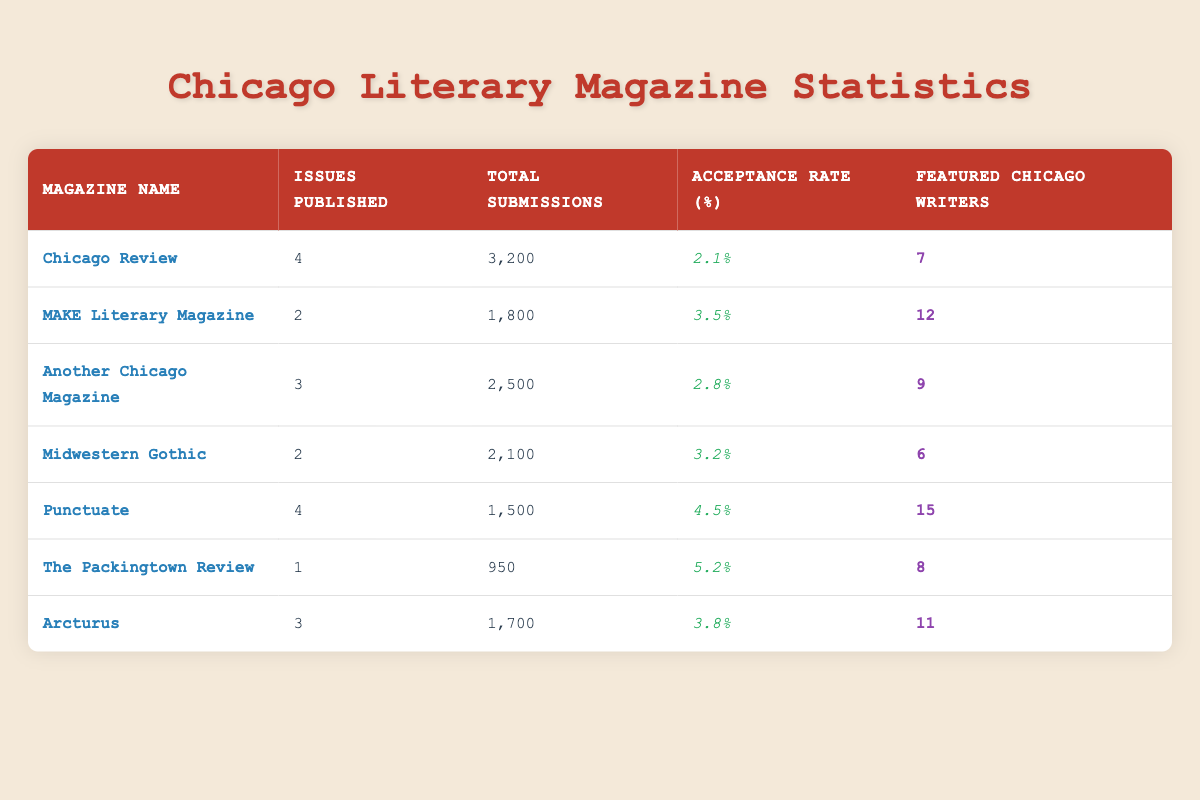What is the Acceptance Rate for Chicago Review? The Acceptance Rate for Chicago Review is located in the respective column next to its name. From the table, it is displayed as 2.1%.
Answer: 2.1% Which magazine published the highest number of issues? By looking at the 'Issues Published' column, the magazines are compared: Chicago Review and Punctuate each published 4 issues, which is the highest among all.
Answer: Chicago Review and Punctuate What is the total number of submissions received by MAKE Literary Magazine? The total submissions for MAKE Literary Magazine can be found in the Total Submissions column, which shows 1,800 submissions.
Answer: 1,800 What is the average Acceptance Rate for all the magazines listed? To find the average Acceptance Rate, add all the rates (2.1 + 3.5 + 2.8 + 3.2 + 4.5 + 5.2 + 3.8) to get a sum of 21.1%. Dividing by the number of magazines (7), the average acceptance rate equals approximately 3.01%.
Answer: 3.01% Is it true that Punctuate featured more writers than Midwestern Gothic? Comparing the number of featured writers, Punctuate has 15 while Midwestern Gothic has 6. Therefore, it is true that Punctuate featured more writers than Midwestern Gothic.
Answer: Yes How many magazines had an Acceptance Rate greater than 3%? By examining the Acceptance Rates: MAKE Literary Magazine (3.5), Midwestern Gothic (3.2), Punctuate (4.5), and The Packingtown Review (5.2), we find that 4 magazines had an Acceptance Rate greater than 3%.
Answer: 4 What is the difference in total submissions between The Packingtown Review and Arcturus? The total submissions for The Packingtown Review and Arcturus are 950 and 1,700, respectively. The difference is found by subtracting: 1,700 - 950 = 750.
Answer: 750 Which magazine has the least number of submissions, and what is that number? Analyzing the Total Submissions column, we see that The Packingtown Review has the least submissions at 950.
Answer: The Packingtown Review; 950 How many Featured Chicago Writers are there in total across all magazines? Summing the 'Featured Chicago Writers' column: 7 + 12 + 9 + 6 + 15 + 8 + 11 gives a total of 68 featured writers across all magazines.
Answer: 68 Is Another Chicago Magazine's number of issues published greater than that of Arcturus? Another Chicago Magazine published 3 issues, while Arcturus published 3 issues as well. Therefore, it is false that Another Chicago Magazine has a greater number of issues published than Arcturus.
Answer: No 